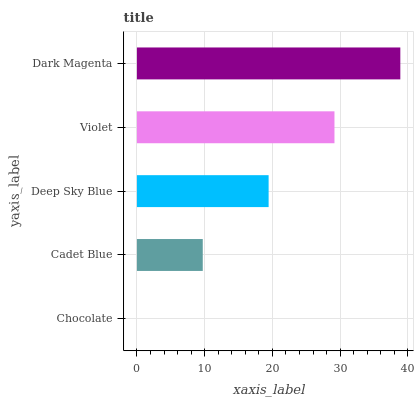Is Chocolate the minimum?
Answer yes or no. Yes. Is Dark Magenta the maximum?
Answer yes or no. Yes. Is Cadet Blue the minimum?
Answer yes or no. No. Is Cadet Blue the maximum?
Answer yes or no. No. Is Cadet Blue greater than Chocolate?
Answer yes or no. Yes. Is Chocolate less than Cadet Blue?
Answer yes or no. Yes. Is Chocolate greater than Cadet Blue?
Answer yes or no. No. Is Cadet Blue less than Chocolate?
Answer yes or no. No. Is Deep Sky Blue the high median?
Answer yes or no. Yes. Is Deep Sky Blue the low median?
Answer yes or no. Yes. Is Violet the high median?
Answer yes or no. No. Is Dark Magenta the low median?
Answer yes or no. No. 